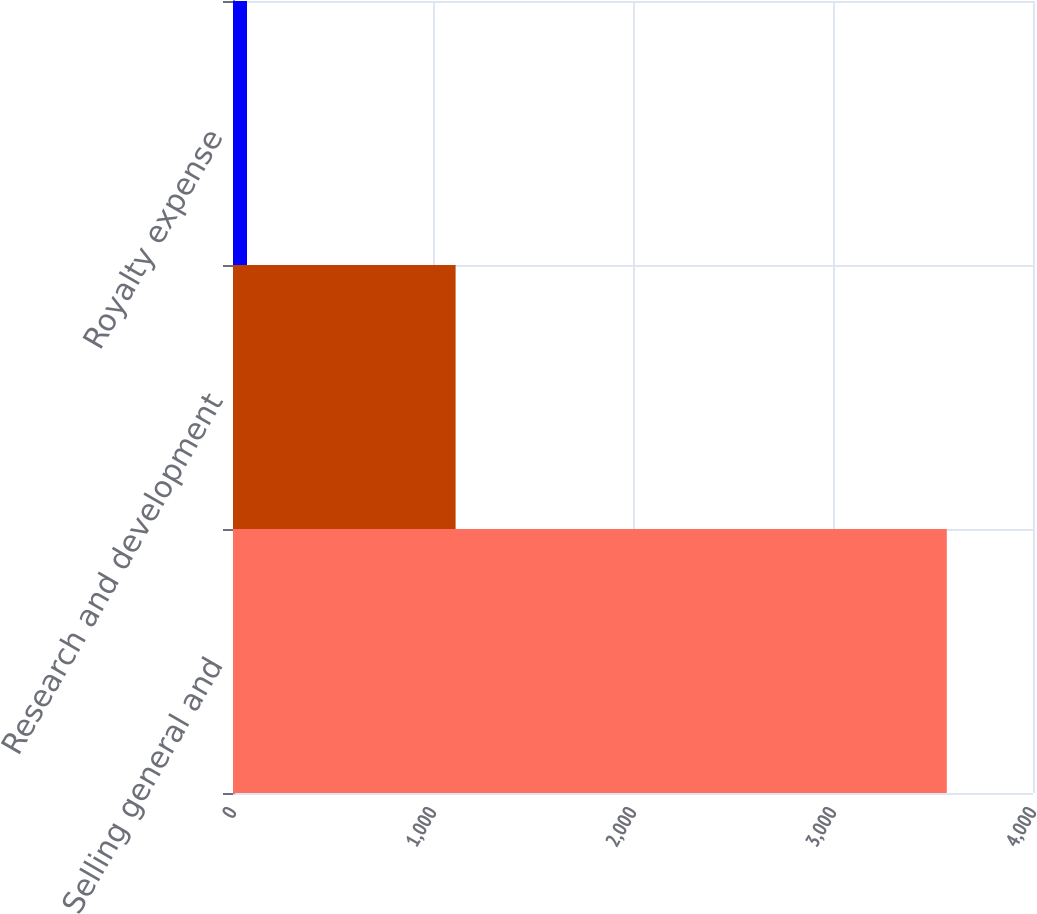Convert chart to OTSL. <chart><loc_0><loc_0><loc_500><loc_500><bar_chart><fcel>Selling general and<fcel>Research and development<fcel>Royalty expense<nl><fcel>3569<fcel>1113<fcel>70<nl></chart> 